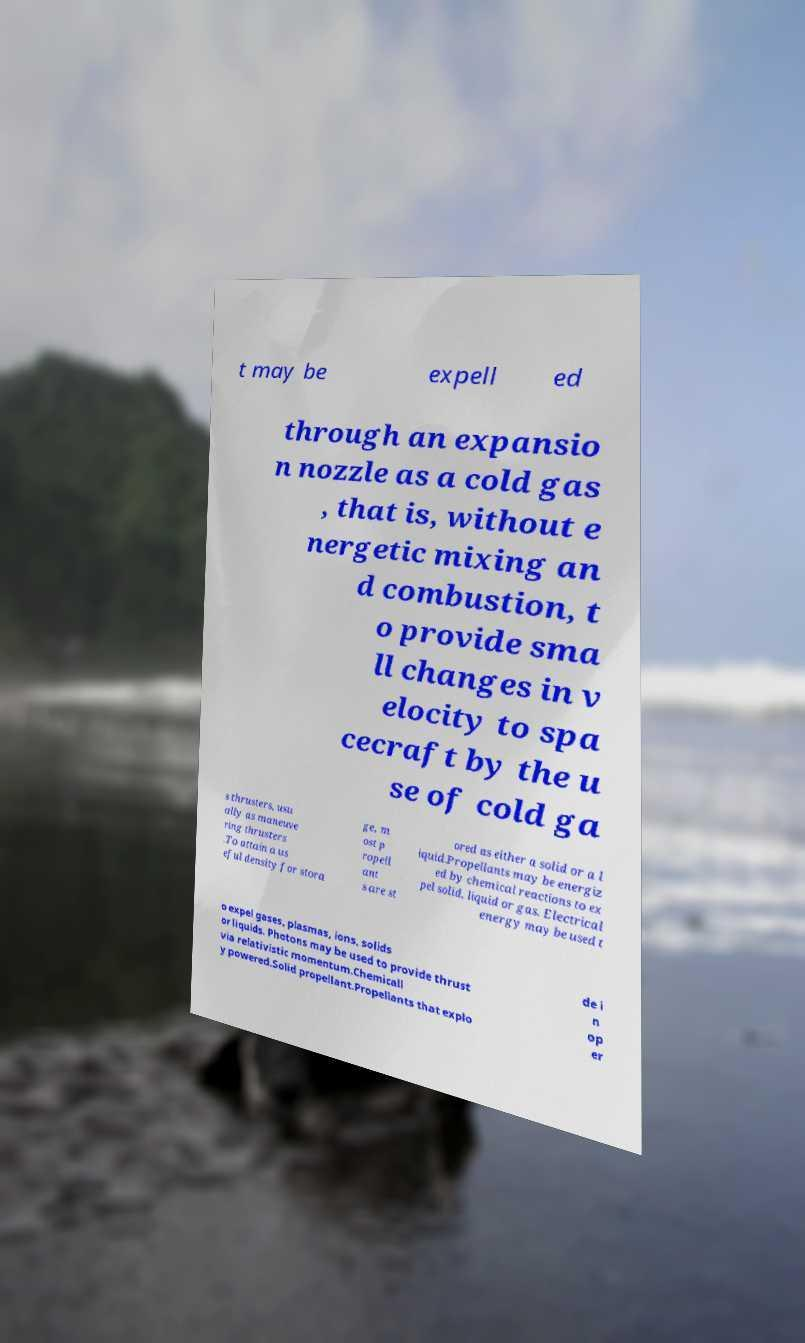For documentation purposes, I need the text within this image transcribed. Could you provide that? t may be expell ed through an expansio n nozzle as a cold gas , that is, without e nergetic mixing an d combustion, t o provide sma ll changes in v elocity to spa cecraft by the u se of cold ga s thrusters, usu ally as maneuve ring thrusters .To attain a us eful density for stora ge, m ost p ropell ant s are st ored as either a solid or a l iquid.Propellants may be energiz ed by chemical reactions to ex pel solid, liquid or gas. Electrical energy may be used t o expel gases, plasmas, ions, solids or liquids. Photons may be used to provide thrust via relativistic momentum.Chemicall y powered.Solid propellant.Propellants that explo de i n op er 